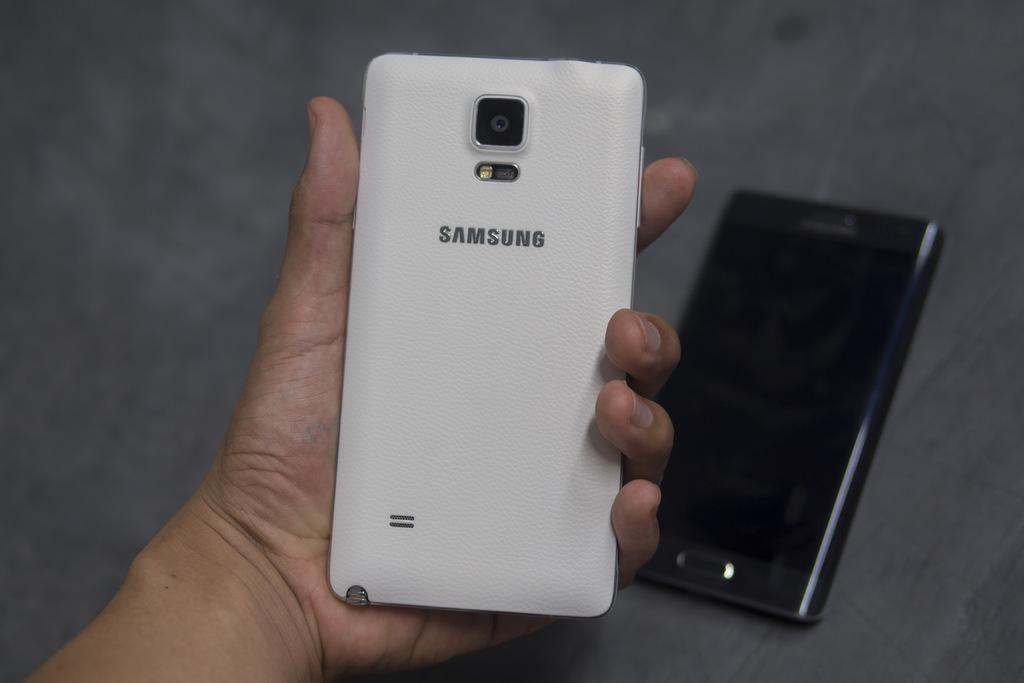<image>
Create a compact narrative representing the image presented. The back of a Samsung phone held in a hand with black phone in the background. 